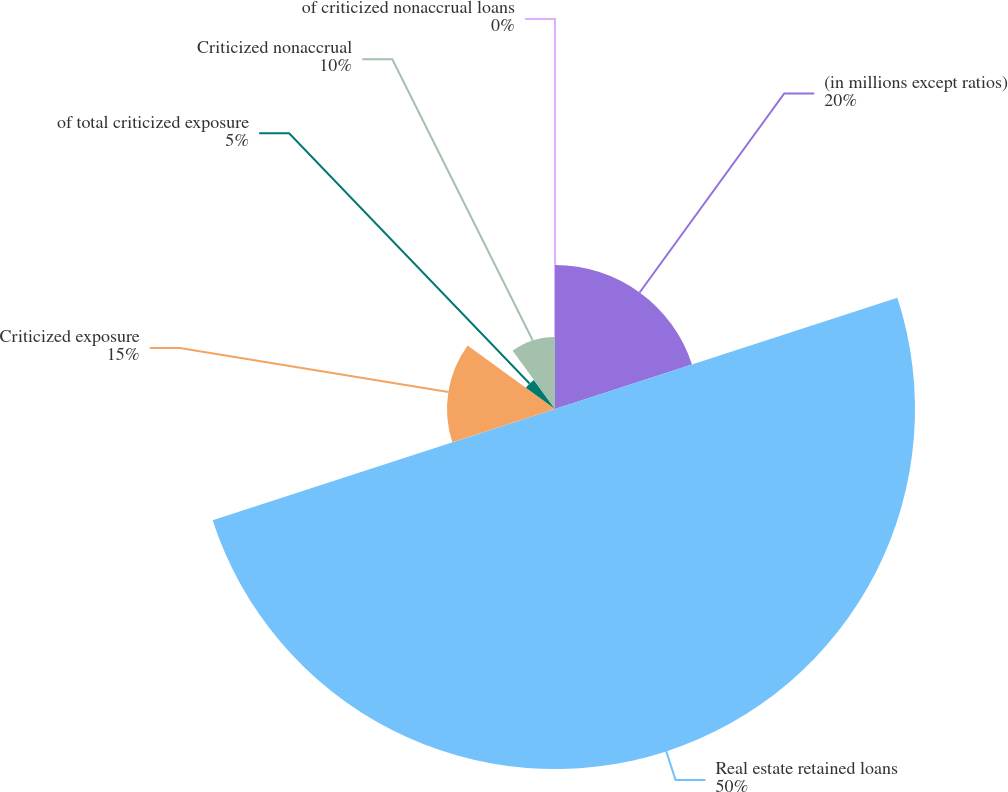<chart> <loc_0><loc_0><loc_500><loc_500><pie_chart><fcel>(in millions except ratios)<fcel>Real estate retained loans<fcel>Criticized exposure<fcel>of total criticized exposure<fcel>Criticized nonaccrual<fcel>of criticized nonaccrual loans<nl><fcel>20.0%<fcel>50.0%<fcel>15.0%<fcel>5.0%<fcel>10.0%<fcel>0.0%<nl></chart> 